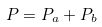Convert formula to latex. <formula><loc_0><loc_0><loc_500><loc_500>P = P _ { a } + P _ { b }</formula> 